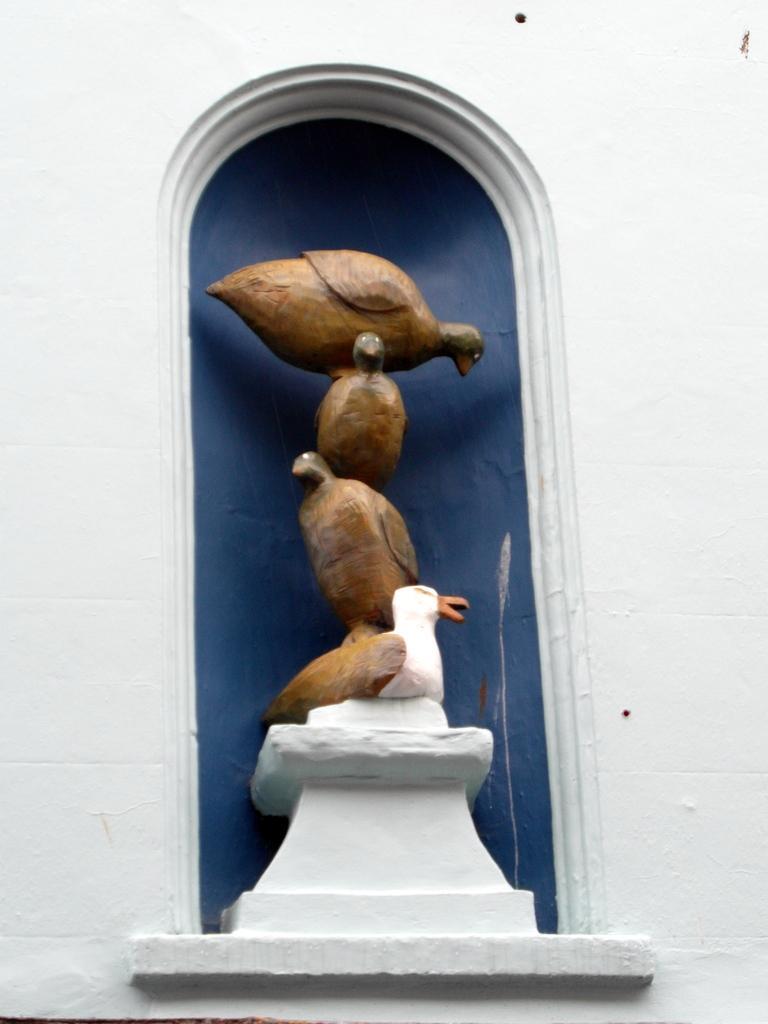Please provide a concise description of this image. In this picture there is a statue of few birds standing one above the other hand there is a wall above it and the background is in blue color. 